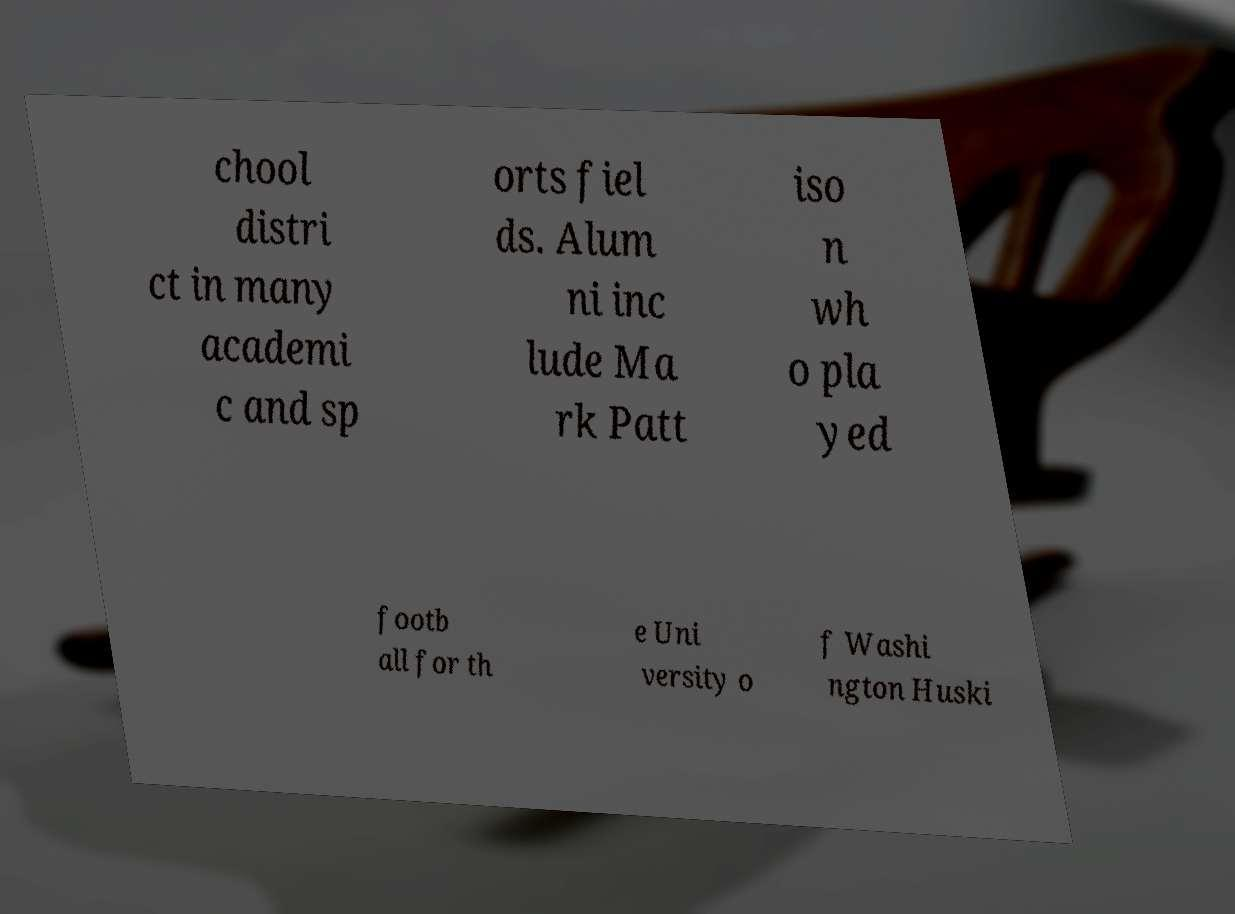There's text embedded in this image that I need extracted. Can you transcribe it verbatim? chool distri ct in many academi c and sp orts fiel ds. Alum ni inc lude Ma rk Patt iso n wh o pla yed footb all for th e Uni versity o f Washi ngton Huski 